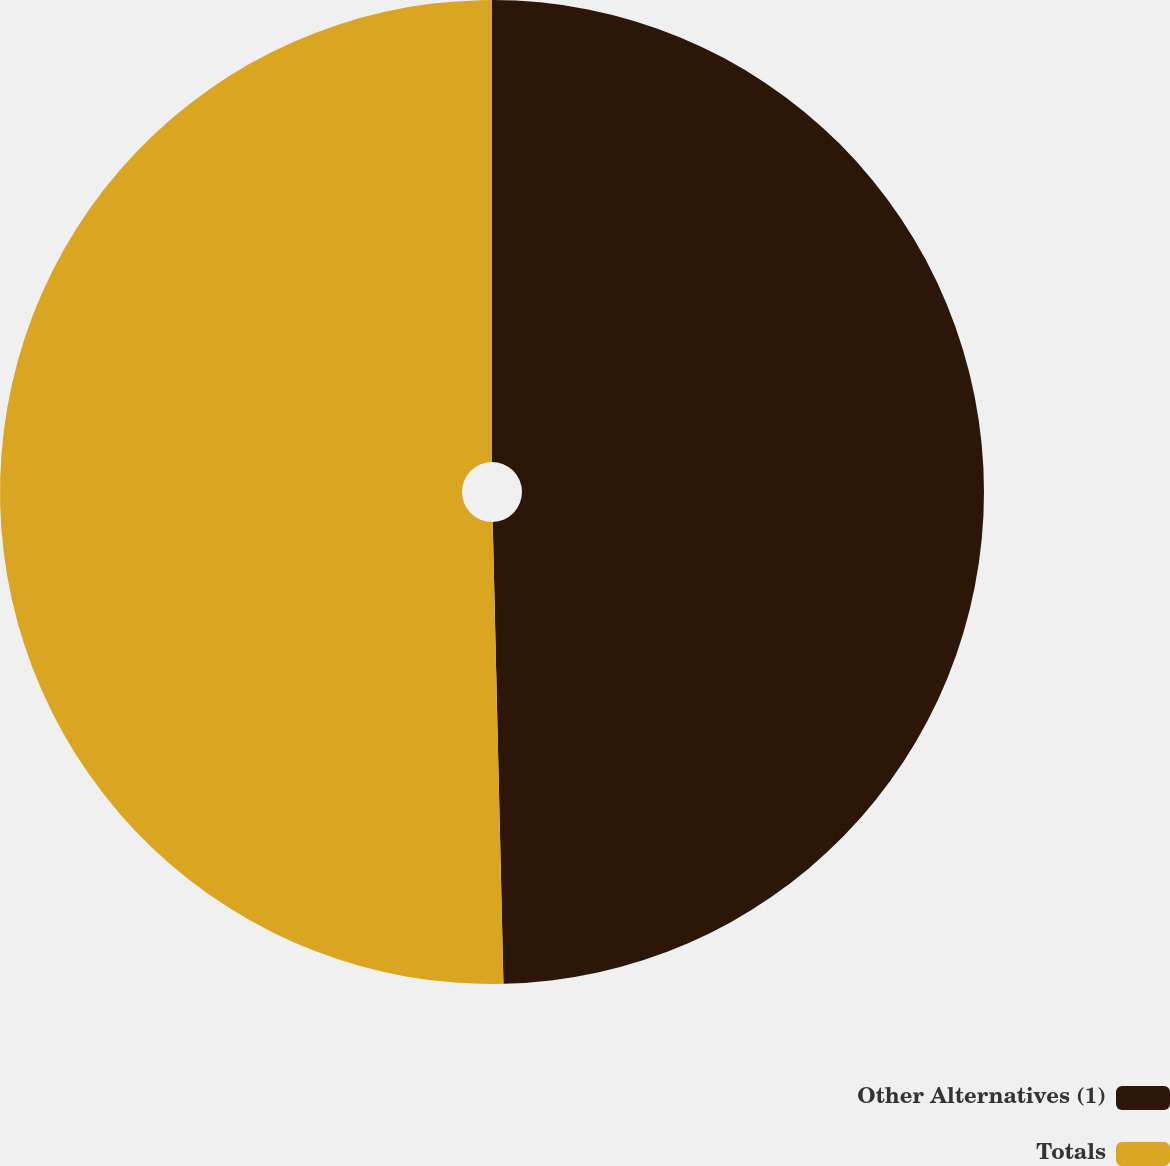Convert chart. <chart><loc_0><loc_0><loc_500><loc_500><pie_chart><fcel>Other Alternatives (1)<fcel>Totals<nl><fcel>49.63%<fcel>50.37%<nl></chart> 